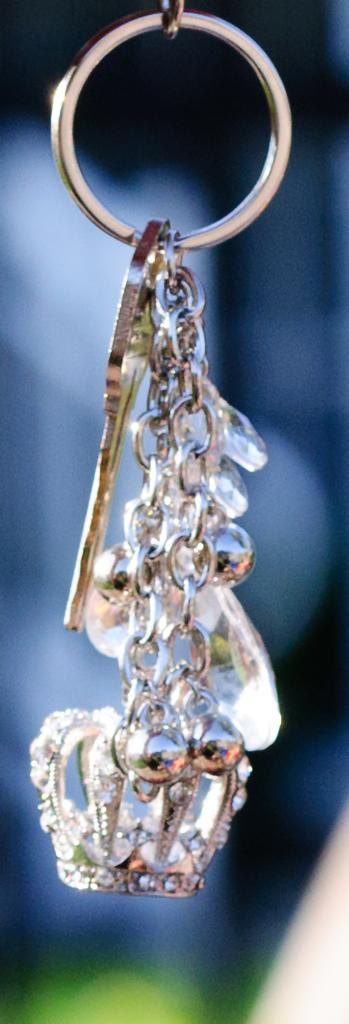What object is the main subject of the image? There is a key chain in the image. What is the color of the key chain? The key chain is white in color. Can you describe the background of the image? The background of the image is blurred. Reasoning: Let' Let's think step by step in order to produce the conversation. We start by identifying the main subject of the image, which is the key chain. Then, we describe the color of the key chain, which is white. Finally, we mention the background of the image, which is blurred. We avoid yes/no questions and ensure that the language is simple and clear. Absurd Question/Answer: How many icicles are hanging from the key chain in the image? There are no icicles present in the image; it features a white key chain with no additional objects. What type of rings are visible on the key chain in the image? There are no rings present on the key chain in the image. What type of debt is associated with the key chain in the image? There is no mention of debt in the image; it features a white key chain with no additional objects or context related to debt. 